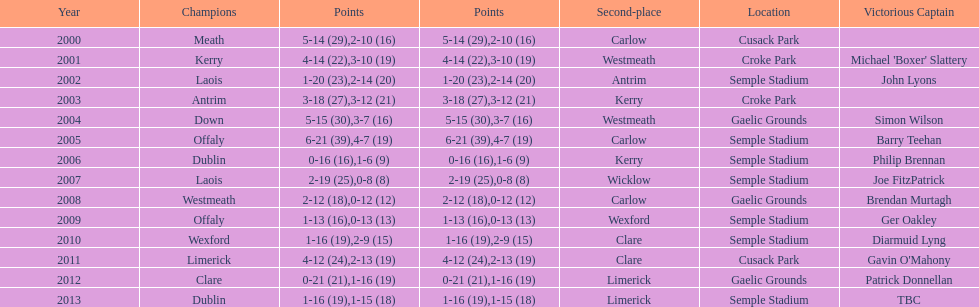Which team was the previous winner before dublin in 2013? Clare. 